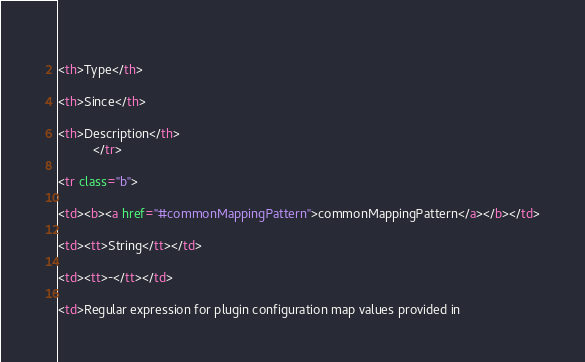<code> <loc_0><loc_0><loc_500><loc_500><_HTML_>            
<th>Type</th>
            
<th>Since</th>
            
<th>Description</th>
          </tr>
          
<tr class="b">
            
<td><b><a href="#commonMappingPattern">commonMappingPattern</a></b></td>
            
<td><tt>String</tt></td>
            
<td><tt>-</tt></td>
            
<td>Regular expression for plugin configuration map values provided in</code> 